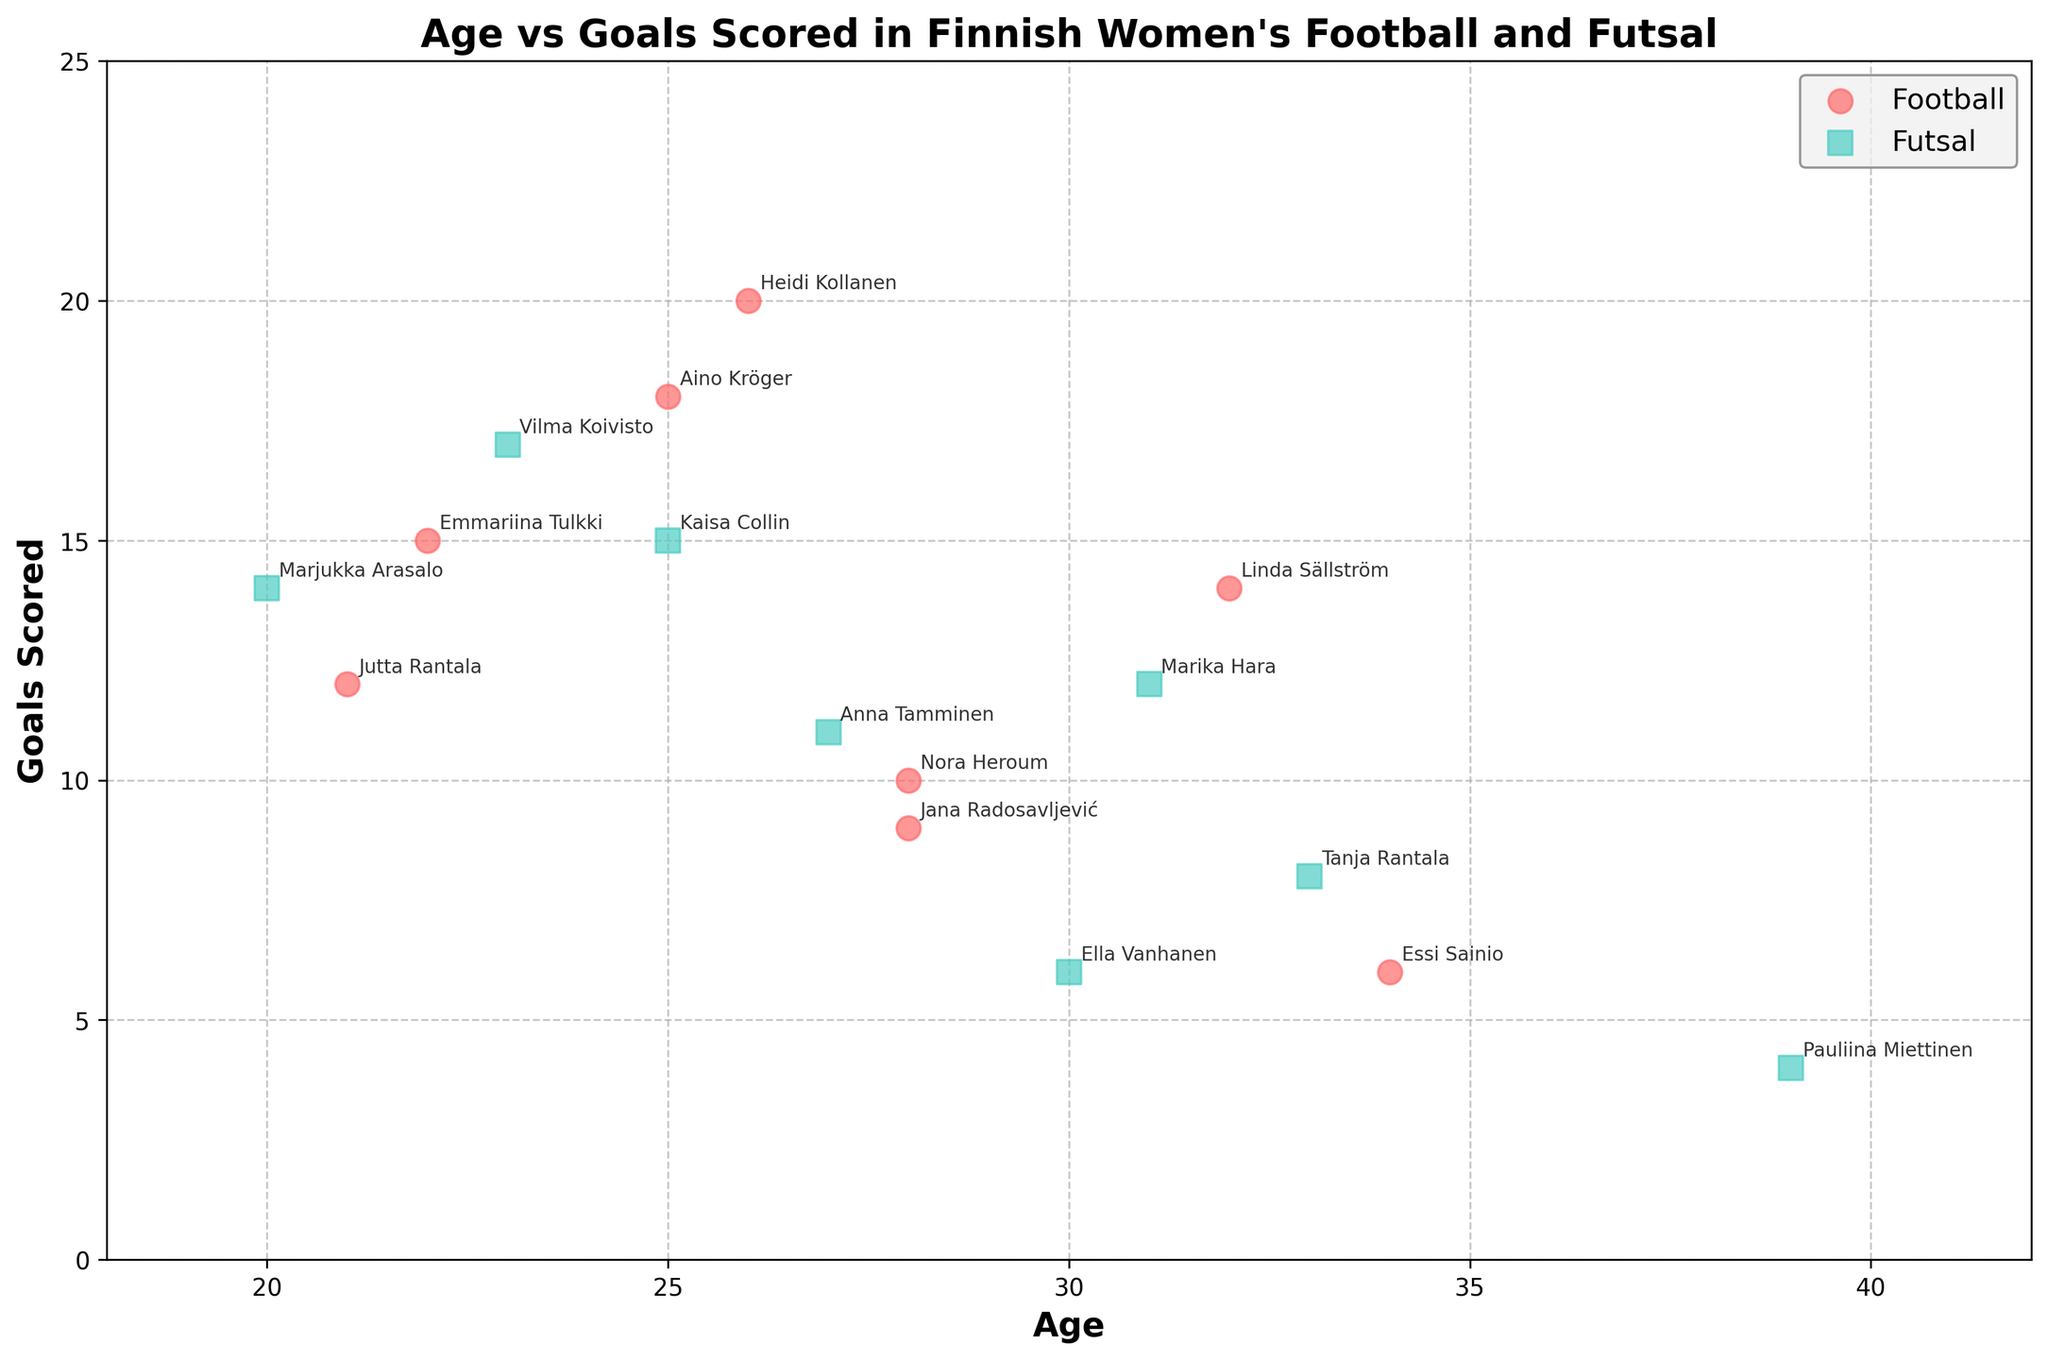What's the relationship between the age and the number of goals scored in Finnish women's football and futsal? In the scatter plot, we observe that goals scored do not consistently increase or decrease with age; instead, there are high-scoring players in both younger and older age groups. This suggests no clear linear relationship.
Answer: No clear linear relationship What is the title of the figure? The title of the figure is positioned at the top center and is written in bold fonts.
Answer: Age vs Goals Scored in Finnish Women's Football and Futsal Which age group has the highest number of goals scored in football? By observing the scatter points and labels, Heidi Kollanen, 26, scored the highest number of goals (20) in football.
Answer: Age 26 (Heidi Kollanen) How many goals has Linda Sällström scored, and in which league does she play? By looking at the scatter plot annotations, Linda Sällström has scored 14 goals and plays in the Naisten Liiga.
Answer: 14 goals in Naisten Liiga Which sport has more players aged 25 scoring goals? By identifying the markers for age 25, we observe one player each for football (Aino Kröger) and futsal (Kaisa Collin). So both sports have an equal number of players.
Answer: Both sports have the same number of players Which sport's players have a wider age range? The ages of football players range from 21 to 34 years, while futsal players range from 20 to 39 years. Hence, futsal players cover a wider age range.
Answer: Futsal Who is the oldest player in the plot and how many goals have they scored? The oldest player, identified by the highest age value on the x-axis, is Pauliina Miettinen (39), who scored 4 goals.
Answer: Pauliina Miettinen (4 goals) Is there a significant difference in the number of goals scored by the youngest players in football and futsal? The youngest players for football (Jutta Rantala, 21) scored 12 goals, and for futsal (Marjukka Arasalo, 20) scored 14 goals. The difference is 2 goals.
Answer: Yes, 2 goals more in futsal How many players aged 30 are there, and what sports do they play? Two players aged 30 can be seen in the scatter plot with different markers: one in football (Ella Vanhanen) and one in futsal (unlabeled).
Answer: 2 players, one in each sport Which sport's highest scorer at age 25 scored more goals and by how much? Comparing the annotations, Aino Kröger (Football) scored 18 goals and Kaisa Collin (Futsal) scored 15 goals at age 25, with football having 3 more goals.
Answer: Football, 3 more goals 